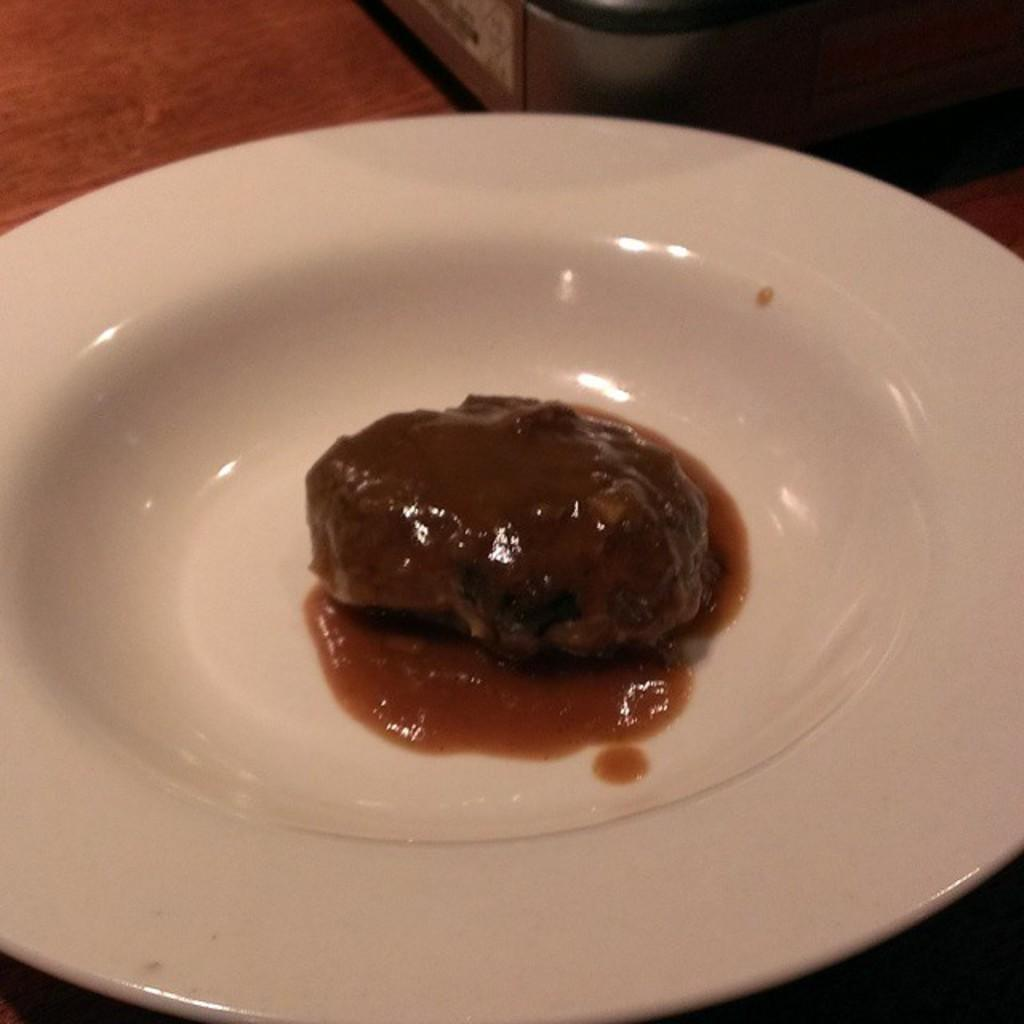What is on the table in the image? There is a plate on the table. What is on the plate? There is food on the plate. Can you describe the object on the table at the top of the image? Unfortunately, the provided facts do not give enough information to describe the object on the table at the top of the image. What type of sponge can be seen performing on the stage in the image? There is no sponge or stage present in the image. 